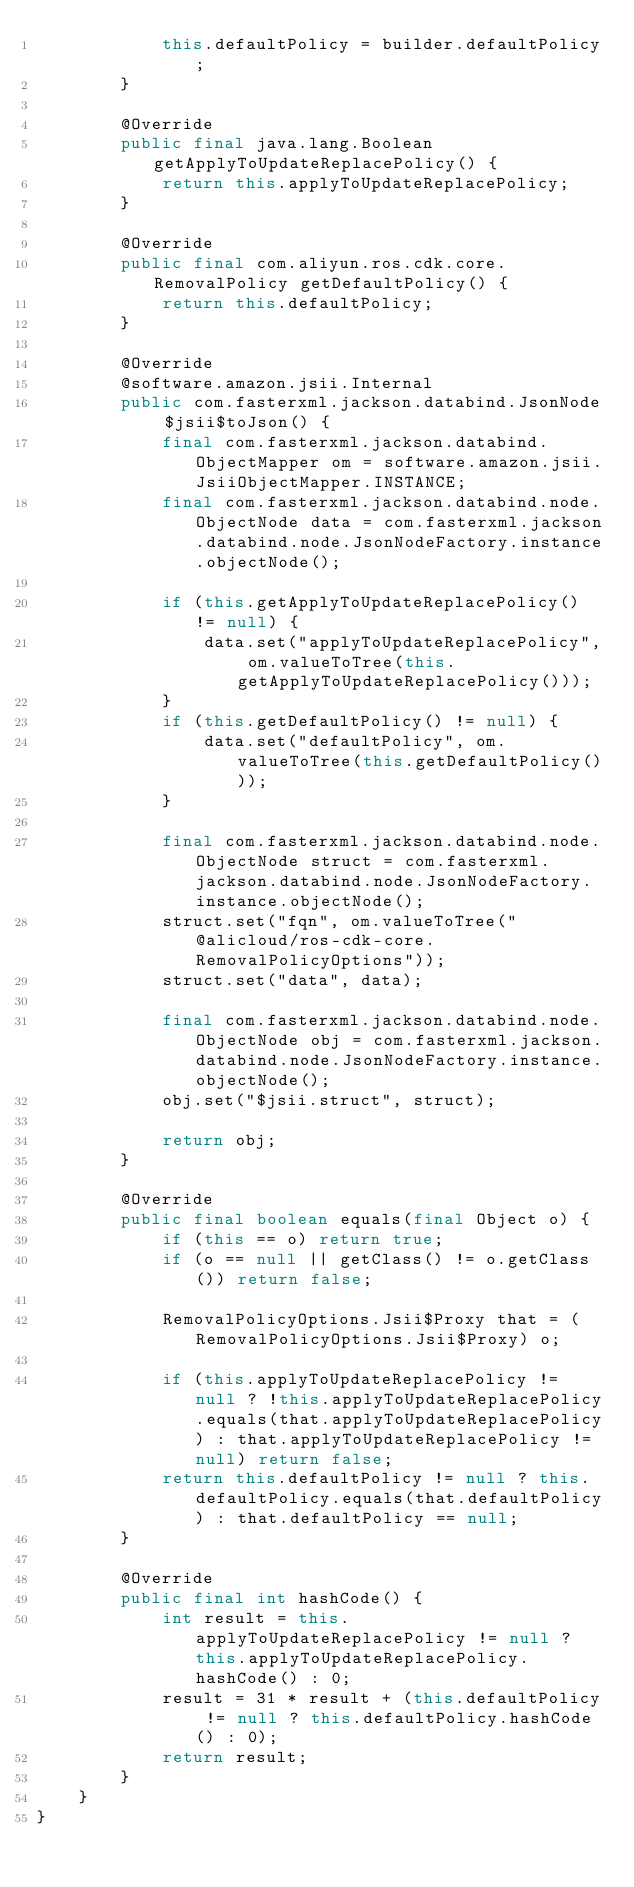<code> <loc_0><loc_0><loc_500><loc_500><_Java_>            this.defaultPolicy = builder.defaultPolicy;
        }

        @Override
        public final java.lang.Boolean getApplyToUpdateReplacePolicy() {
            return this.applyToUpdateReplacePolicy;
        }

        @Override
        public final com.aliyun.ros.cdk.core.RemovalPolicy getDefaultPolicy() {
            return this.defaultPolicy;
        }

        @Override
        @software.amazon.jsii.Internal
        public com.fasterxml.jackson.databind.JsonNode $jsii$toJson() {
            final com.fasterxml.jackson.databind.ObjectMapper om = software.amazon.jsii.JsiiObjectMapper.INSTANCE;
            final com.fasterxml.jackson.databind.node.ObjectNode data = com.fasterxml.jackson.databind.node.JsonNodeFactory.instance.objectNode();

            if (this.getApplyToUpdateReplacePolicy() != null) {
                data.set("applyToUpdateReplacePolicy", om.valueToTree(this.getApplyToUpdateReplacePolicy()));
            }
            if (this.getDefaultPolicy() != null) {
                data.set("defaultPolicy", om.valueToTree(this.getDefaultPolicy()));
            }

            final com.fasterxml.jackson.databind.node.ObjectNode struct = com.fasterxml.jackson.databind.node.JsonNodeFactory.instance.objectNode();
            struct.set("fqn", om.valueToTree("@alicloud/ros-cdk-core.RemovalPolicyOptions"));
            struct.set("data", data);

            final com.fasterxml.jackson.databind.node.ObjectNode obj = com.fasterxml.jackson.databind.node.JsonNodeFactory.instance.objectNode();
            obj.set("$jsii.struct", struct);

            return obj;
        }

        @Override
        public final boolean equals(final Object o) {
            if (this == o) return true;
            if (o == null || getClass() != o.getClass()) return false;

            RemovalPolicyOptions.Jsii$Proxy that = (RemovalPolicyOptions.Jsii$Proxy) o;

            if (this.applyToUpdateReplacePolicy != null ? !this.applyToUpdateReplacePolicy.equals(that.applyToUpdateReplacePolicy) : that.applyToUpdateReplacePolicy != null) return false;
            return this.defaultPolicy != null ? this.defaultPolicy.equals(that.defaultPolicy) : that.defaultPolicy == null;
        }

        @Override
        public final int hashCode() {
            int result = this.applyToUpdateReplacePolicy != null ? this.applyToUpdateReplacePolicy.hashCode() : 0;
            result = 31 * result + (this.defaultPolicy != null ? this.defaultPolicy.hashCode() : 0);
            return result;
        }
    }
}
</code> 